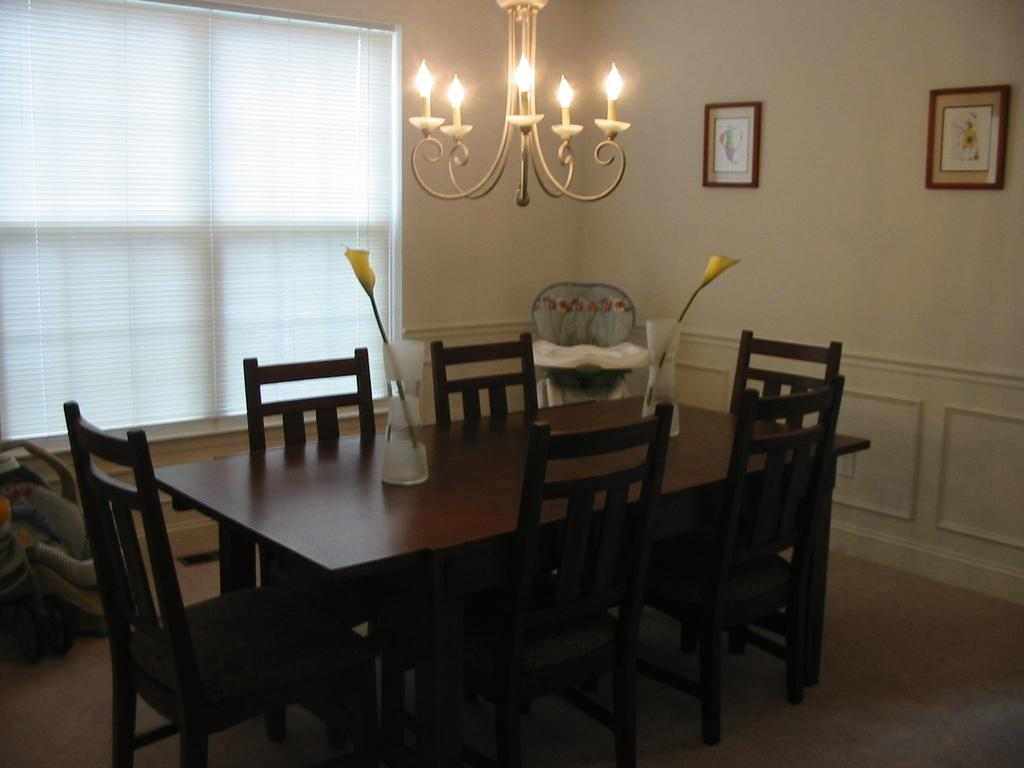What type of furniture is present in the image? There is a dining table in the image. What is the purpose of the baby pram in the image? The baby pram is likely used for transporting or carrying a baby. What type of lighting fixture is hanging from the top in the image? A chandelier is hanging from the top in the image. What is the purpose of the sink in the image? The sink is likely used for washing dishes or hands. What decorative items are present on the dining table? Flower vases are present on the dining table. What type of wall decorations are attached to the wall in the image? Wall hangings are attached to the wall in the image. What type of window treatment is associated with the window in the image? Blinds are associated with the window in the image. What type of lace is used to decorate the baby pram in the image? There is no mention of lace in the image, and the baby pram does not appear to be decorated with lace. What type of sign is hanging from the top in the image? There is no sign present in the image; only a chandelier is mentioned. 